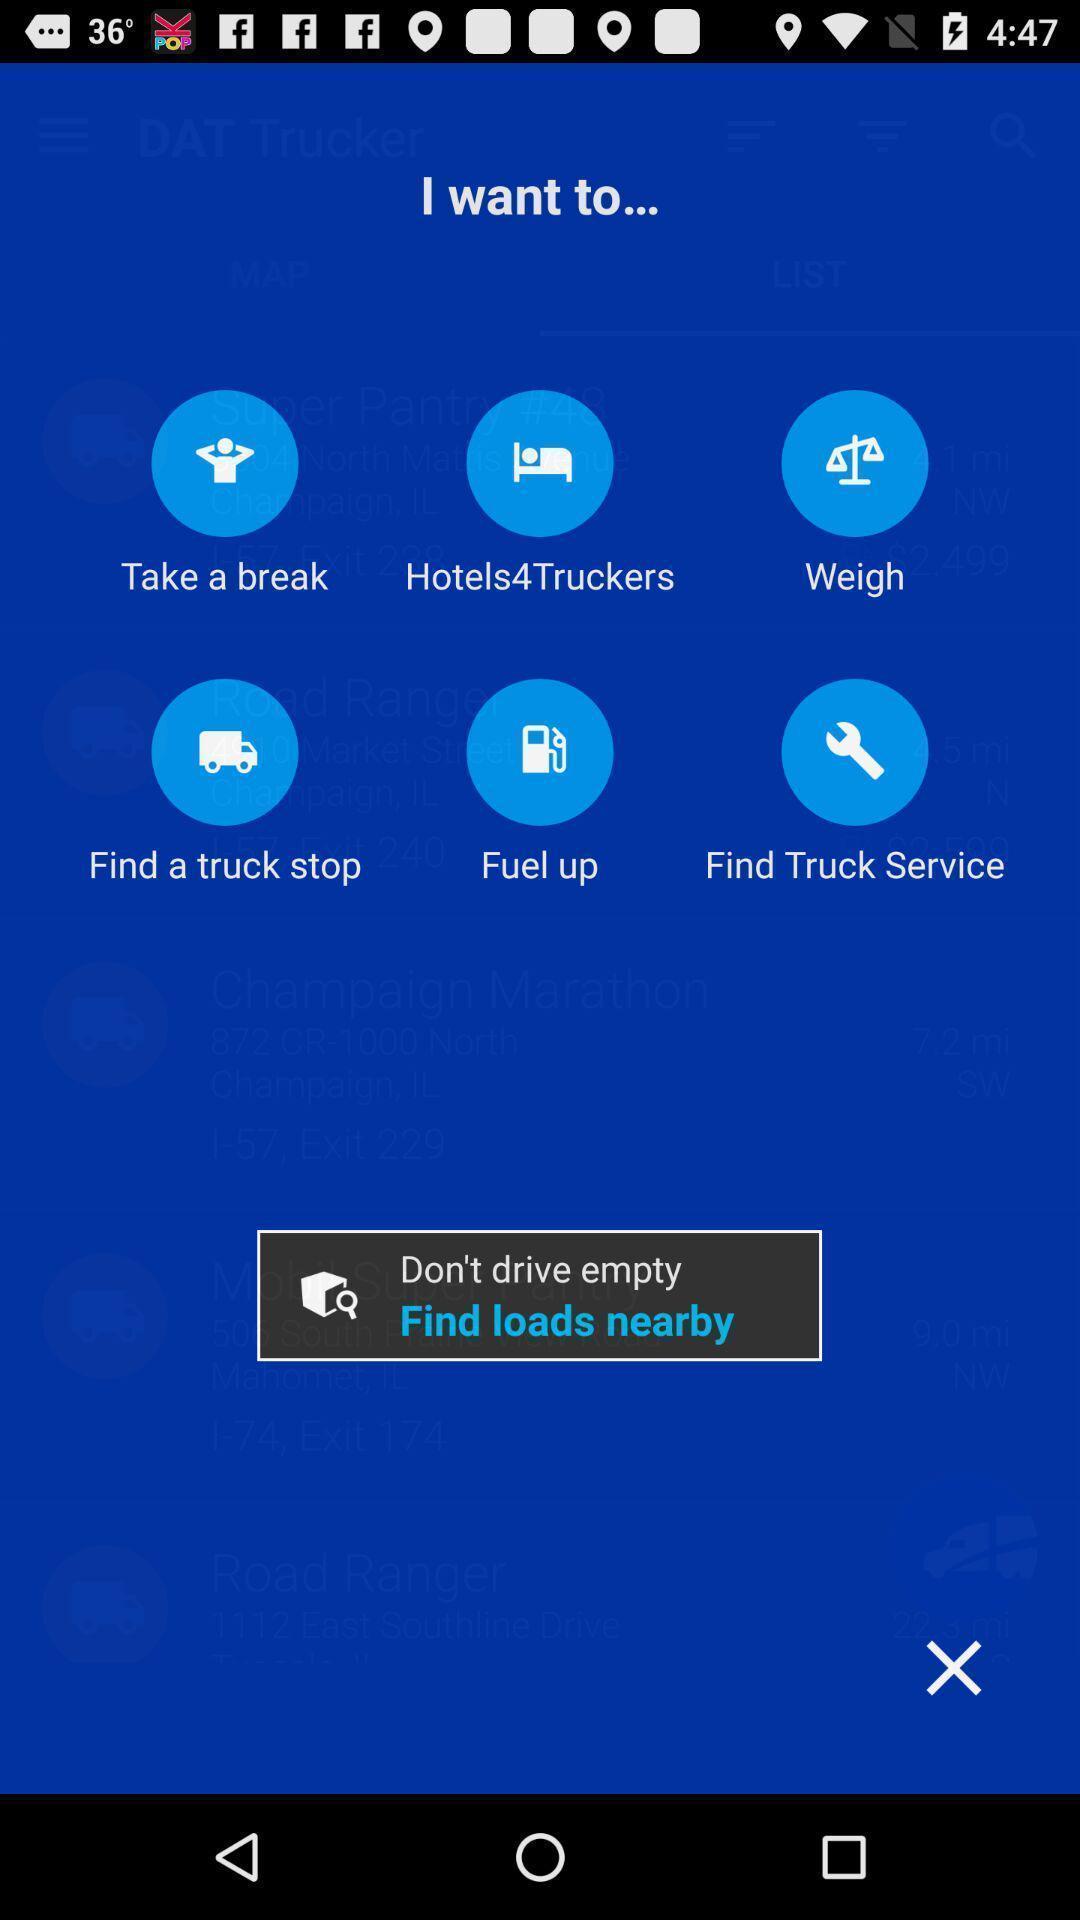Describe the content in this image. Pop up displaying multiple service options in a trucker application. 